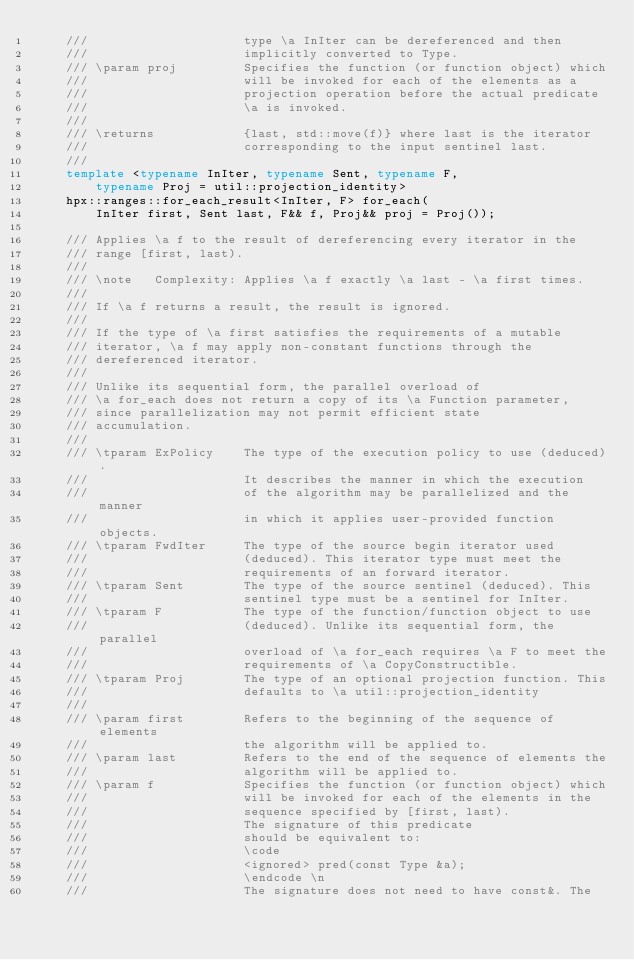Convert code to text. <code><loc_0><loc_0><loc_500><loc_500><_C++_>    ///                     type \a InIter can be dereferenced and then
    ///                     implicitly converted to Type.
    /// \param proj         Specifies the function (or function object) which
    ///                     will be invoked for each of the elements as a
    ///                     projection operation before the actual predicate
    ///                     \a is invoked.
    ///
    /// \returns            {last, std::move(f)} where last is the iterator
    ///                     corresponding to the input sentinel last.
    ///
    template <typename InIter, typename Sent, typename F,
        typename Proj = util::projection_identity>
    hpx::ranges::for_each_result<InIter, F> for_each(
        InIter first, Sent last, F&& f, Proj&& proj = Proj());

    /// Applies \a f to the result of dereferencing every iterator in the
    /// range [first, last).
    ///
    /// \note   Complexity: Applies \a f exactly \a last - \a first times.
    ///
    /// If \a f returns a result, the result is ignored.
    ///
    /// If the type of \a first satisfies the requirements of a mutable
    /// iterator, \a f may apply non-constant functions through the
    /// dereferenced iterator.
    ///
    /// Unlike its sequential form, the parallel overload of
    /// \a for_each does not return a copy of its \a Function parameter,
    /// since parallelization may not permit efficient state
    /// accumulation.
    ///
    /// \tparam ExPolicy    The type of the execution policy to use (deduced).
    ///                     It describes the manner in which the execution
    ///                     of the algorithm may be parallelized and the manner
    ///                     in which it applies user-provided function objects.
    /// \tparam FwdIter     The type of the source begin iterator used
    ///                     (deduced). This iterator type must meet the
    ///                     requirements of an forward iterator.
    /// \tparam Sent        The type of the source sentinel (deduced). This
    ///                     sentinel type must be a sentinel for InIter.
    /// \tparam F           The type of the function/function object to use
    ///                     (deduced). Unlike its sequential form, the parallel
    ///                     overload of \a for_each requires \a F to meet the
    ///                     requirements of \a CopyConstructible.
    /// \tparam Proj        The type of an optional projection function. This
    ///                     defaults to \a util::projection_identity
    ///
    /// \param first        Refers to the beginning of the sequence of elements
    ///                     the algorithm will be applied to.
    /// \param last         Refers to the end of the sequence of elements the
    ///                     algorithm will be applied to.
    /// \param f            Specifies the function (or function object) which
    ///                     will be invoked for each of the elements in the
    ///                     sequence specified by [first, last).
    ///                     The signature of this predicate
    ///                     should be equivalent to:
    ///                     \code
    ///                     <ignored> pred(const Type &a);
    ///                     \endcode \n
    ///                     The signature does not need to have const&. The</code> 